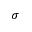<formula> <loc_0><loc_0><loc_500><loc_500>\sigma</formula> 